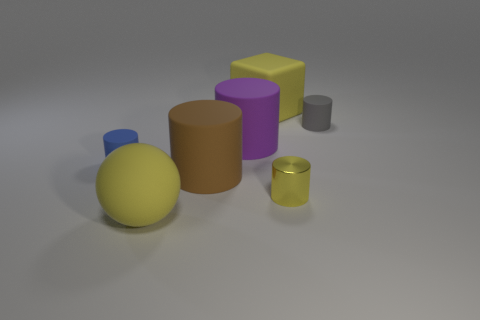Is there any other thing that is made of the same material as the tiny yellow cylinder?
Ensure brevity in your answer.  No. There is a cylinder that is left of the large yellow object in front of the gray cylinder; what number of large cylinders are behind it?
Offer a very short reply. 1. Do the tiny yellow thing and the small rubber thing that is right of the big cube have the same shape?
Provide a short and direct response. Yes. Are there more tiny yellow shiny cylinders than small matte cylinders?
Ensure brevity in your answer.  No. Is there any other thing that has the same size as the purple thing?
Make the answer very short. Yes. Do the tiny matte object that is left of the tiny metallic cylinder and the tiny yellow metallic thing have the same shape?
Offer a terse response. Yes. Is the number of large purple matte cylinders in front of the purple rubber thing greater than the number of big blue blocks?
Your response must be concise. No. There is a tiny thing left of the yellow rubber thing in front of the brown object; what is its color?
Provide a short and direct response. Blue. How many small cylinders are there?
Your response must be concise. 3. How many yellow things are both to the left of the tiny yellow shiny object and to the right of the purple cylinder?
Offer a terse response. 1. 